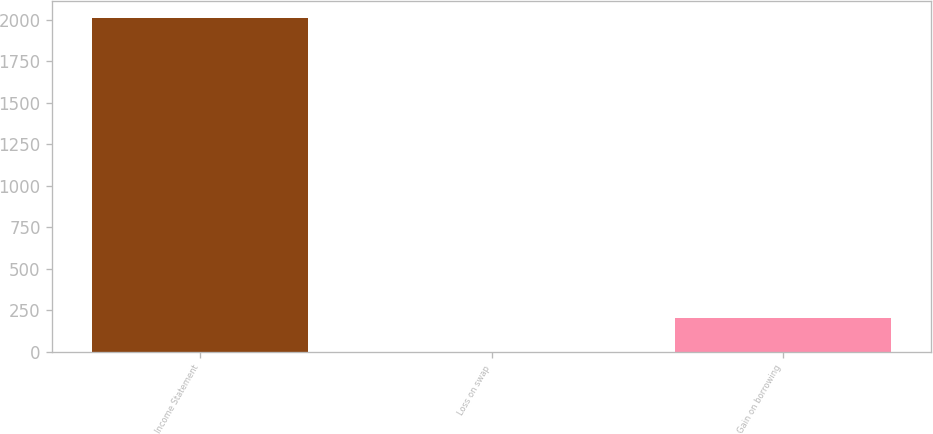Convert chart to OTSL. <chart><loc_0><loc_0><loc_500><loc_500><bar_chart><fcel>Income Statement<fcel>Loss on swap<fcel>Gain on borrowing<nl><fcel>2014<fcel>1<fcel>202.3<nl></chart> 